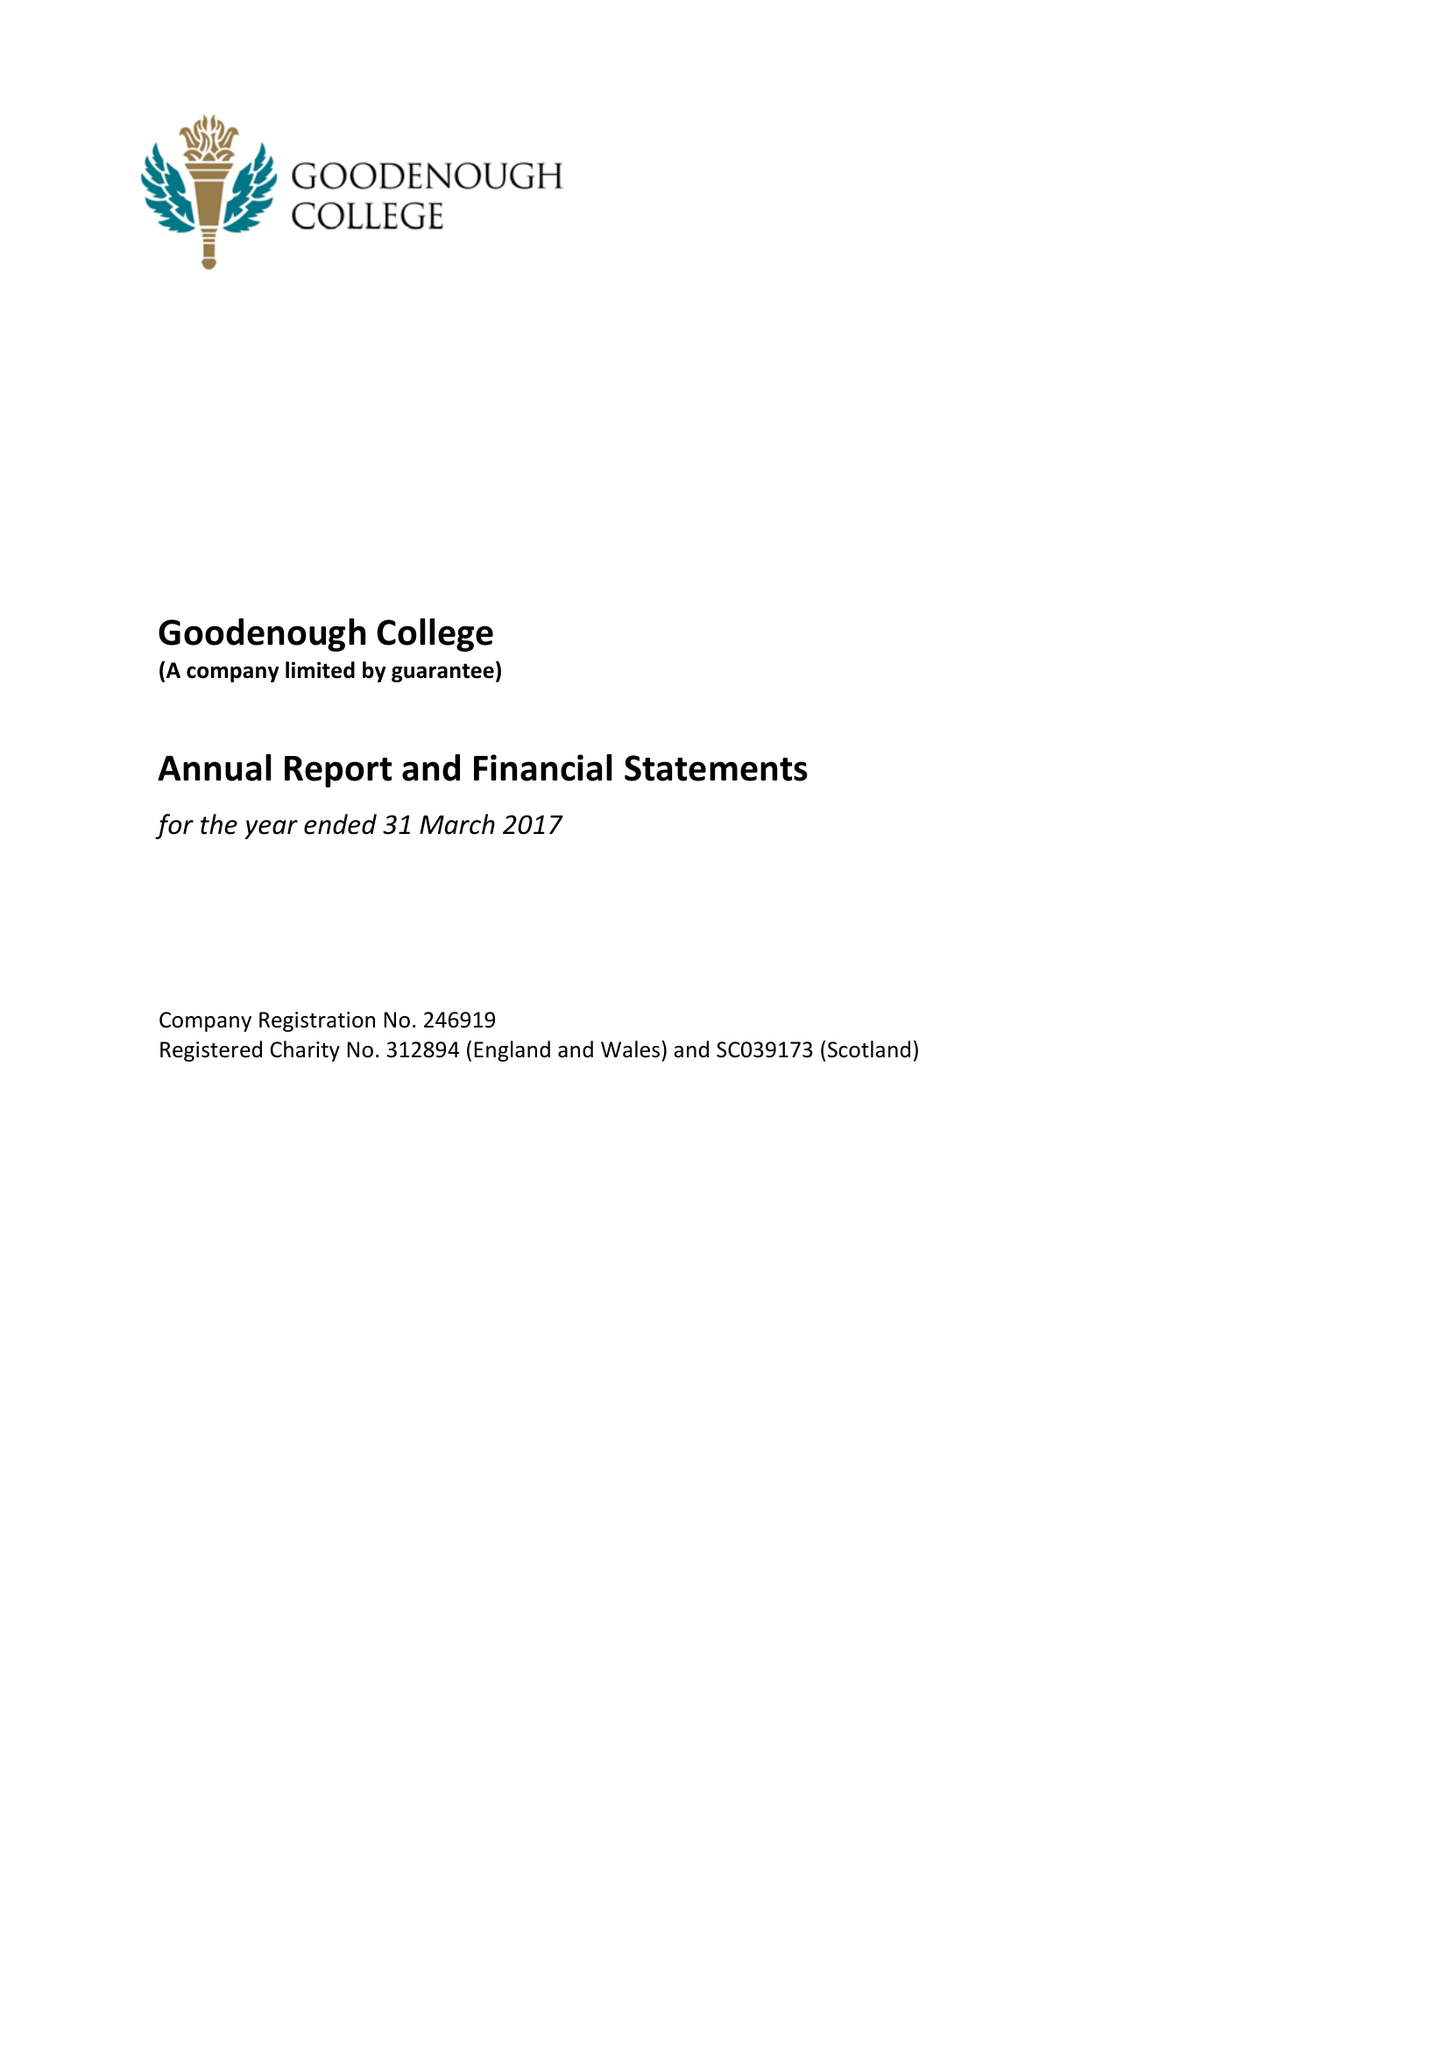What is the value for the address__post_town?
Answer the question using a single word or phrase. LONDON 